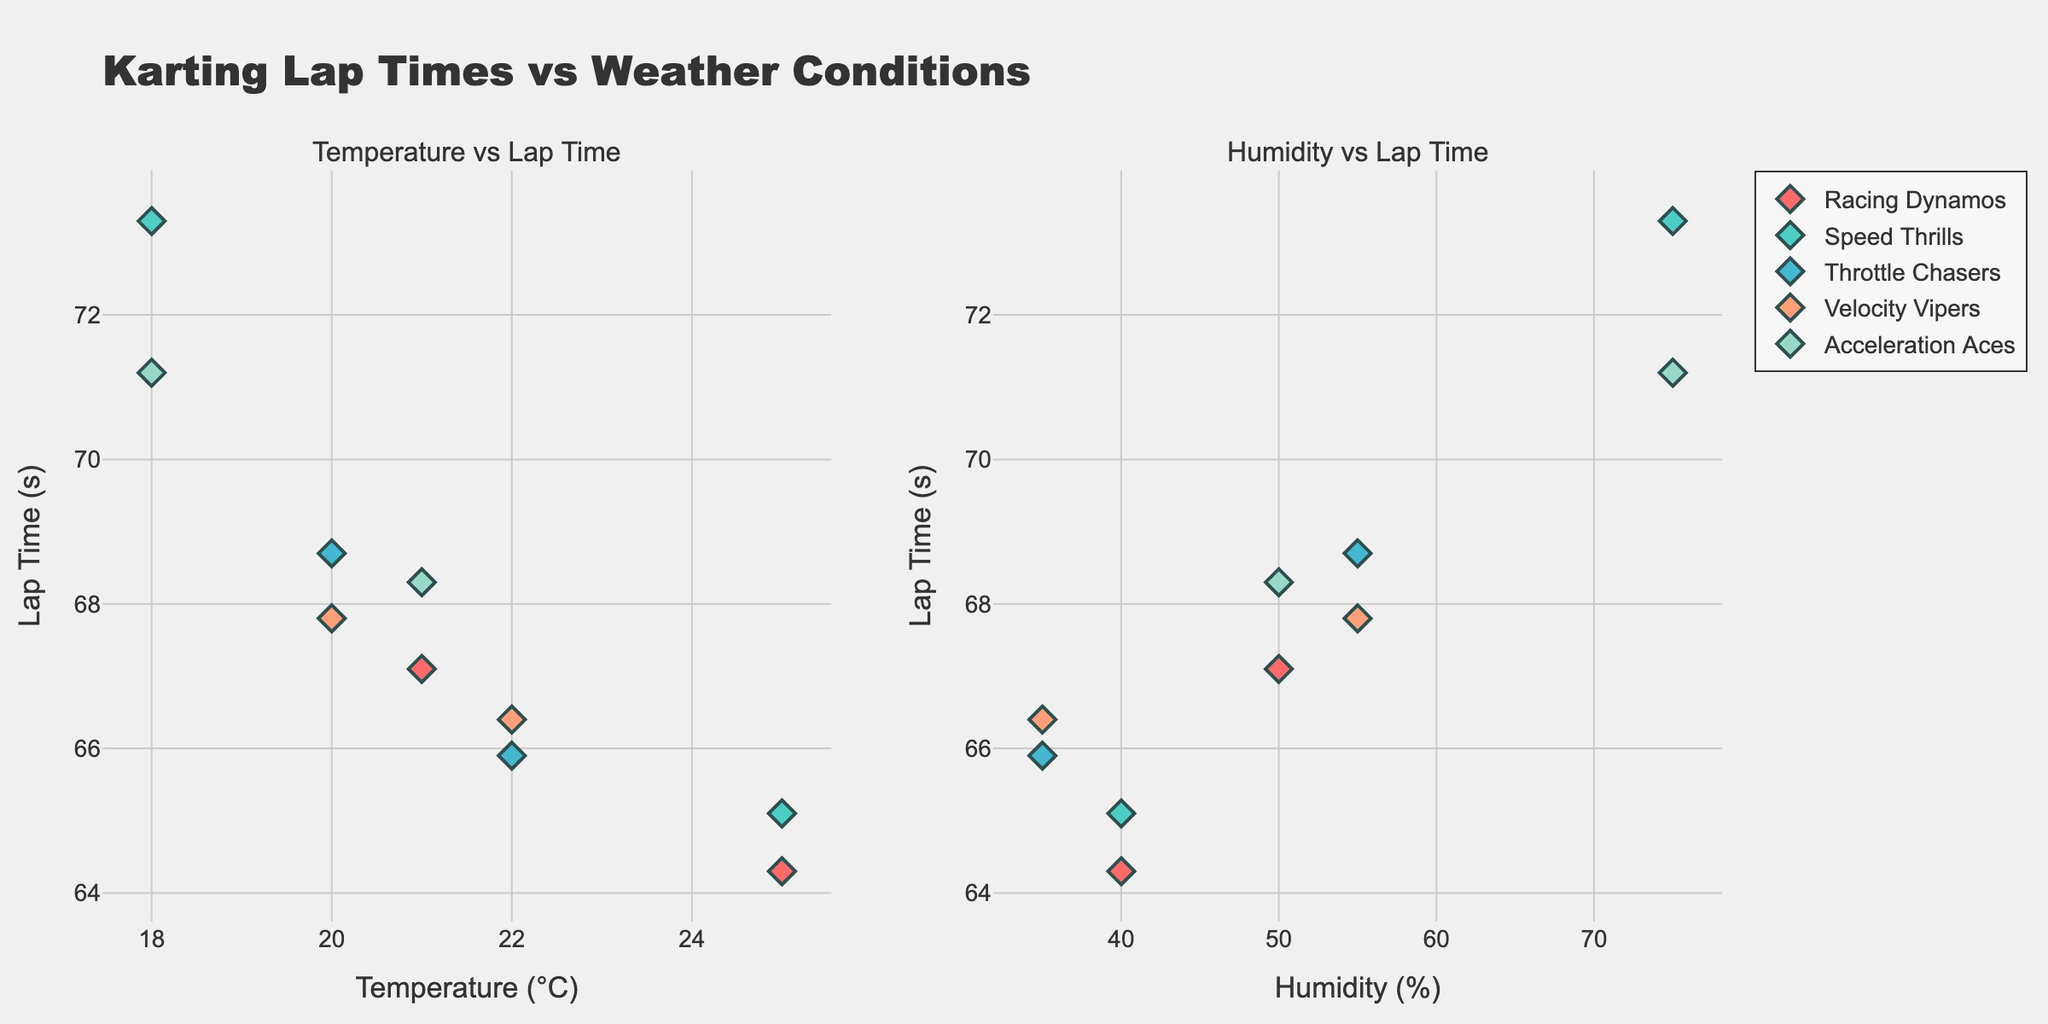What is the title of the subplot? The title of the subplot is usually located at the top of the figure where it summarizes the main idea or focus of the data being displayed. In this case, the title provides an overview of what the figure represents.
Answer: Karting Lap Times vs Weather Conditions Which team has the most data points in the "Temperature vs Lap Time" plot? To find this, you need to count the markers for each team in the "Temperature vs Lap Time" subplot. The team with the highest count has the most data points.
Answer: Speed Thrills What is the lap time for Lucas Smith and under what weather condition was it recorded? Locate the point or marker associated with Lucas Smith by looking at the hover template or legend related to Racing Dynamos. Check the 'Temperature vs Lap Time' plot. The weather condition and the lap time will be displayed there.
Answer: 64.3s, Sunny Which weather condition shows the highest lap time and which driver recorded it? To find this, identify the maximum y-value (lap time) in both subplots and then check the associated weather condition and driver from the hover template or markers.
Answer: 73.3s, Emma Wilson, Rainy Compare the lap times of drivers from Throttle Chasers. Who is faster and by how much? Locate the markers for Throttle Chasers in both subplots. Compare Max Turner and Liam Davis’s lap times by looking at the y-axis values corresponding to their points.
Answer: Liam Davis is faster by 2.8s What is the range of temperatures recorded in the "Temperature vs Lap Time" plot? Find the minimum and maximum values along the x-axis in the "Temperature vs Lap Time" subplot. Subtract the minimum value from the maximum value to get the range.
Answer: 18°C to 25°C Was the lap time affected more by temperature or humidity? Compare the spread and correlation of lap times against temperature in the "Temperature vs Lap Time" plot and against humidity in the "Humidity vs Lap Time" plot. A tighter correlation or more uniform spread indicates a stronger effect.
Answer: Temperature Which plot shows a clearer correlation between lap times and the x-axis variable? Evaluate the pattern or trend of the scatter points in both subplots. A clearer pattern signifies a stronger correlation.
Answer: Temperature vs Lap Time On which date were the lap times the most consistent? Analyze the vertical spread of data points for each date. Consistent lap times will have points that are closely packed together vertically.
Answer: 2023-09-15 Which driver recorded a lap time in windy conditions and what was their time? Look for markers associated with the "Windy" weather condition in either subplot and check the driver name linked to those points. Find the corresponding lap time.
Answer: Ethan Clark, 67.1s 